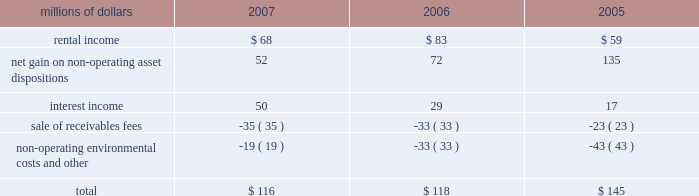Be resolved , we cannot reasonably determine the probability of an adverse claim or reasonably estimate any adverse liability or the total maximum exposure under these indemnification arrangements .
We do not have any reason to believe that we will be required to make any material payments under these indemnity provisions .
Income taxes 2013 as discussed in note 4 , the irs has completed its examinations and issued notices of deficiency for tax years 1995 through 2004 , and we are in different stages of the irs appeals process for these years .
The irs is examining our tax returns for tax years 2005 and 2006 .
In the third quarter of 2007 , we believe that we reached an agreement in principle with the irs to resolve all of the issues , except interest , related to tax years 1995 through 1998 , including the previously reported dispute over certain donations of property .
We anticipate signing a closing agreement in 2008 .
At december 31 , 2007 , we have recorded a current liability of $ 140 million for tax payments in 2008 related to federal and state income tax examinations .
We do not expect that the ultimate resolution of these examinations will have a material adverse effect on our consolidated financial statements .
11 .
Other income other income included the following for the years ended december 31 : millions of dollars 2007 2006 2005 .
12 .
Share repurchase program on january 30 , 2007 , our board of directors authorized the repurchase of up to 20 million shares of union pacific corporation common stock through the end of 2009 .
Management 2019s assessments of market conditions and other pertinent facts guide the timing and volume of all repurchases .
We expect to fund our common stock repurchases through cash generated from operations , the sale or lease of various operating and non- operating properties , debt issuances , and cash on hand at december 31 , 2007 .
During 2007 , we repurchased approximately 13 million shares under this program at an aggregate purchase price of approximately $ 1.5 billion .
These shares were recorded in treasury stock at cost , which includes any applicable commissions and fees. .
What percent of total other income was rental income in 2006? 
Computations: (83 / 118)
Answer: 0.70339. 